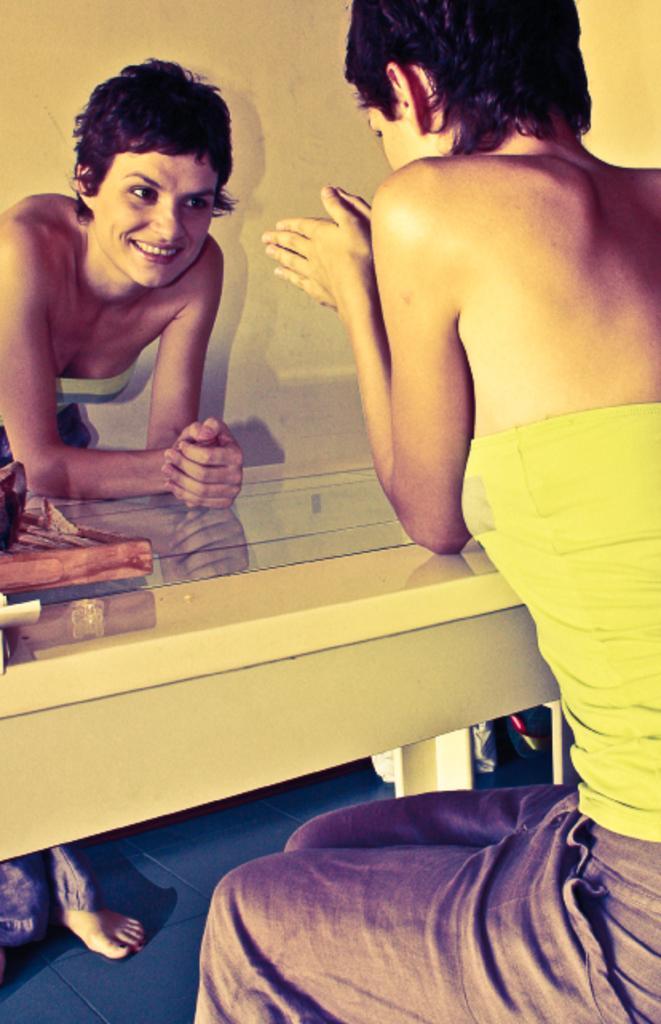Can you describe this image briefly? There are two persons and this person sitting. we can see table on the floor. On the background we can see wall. 